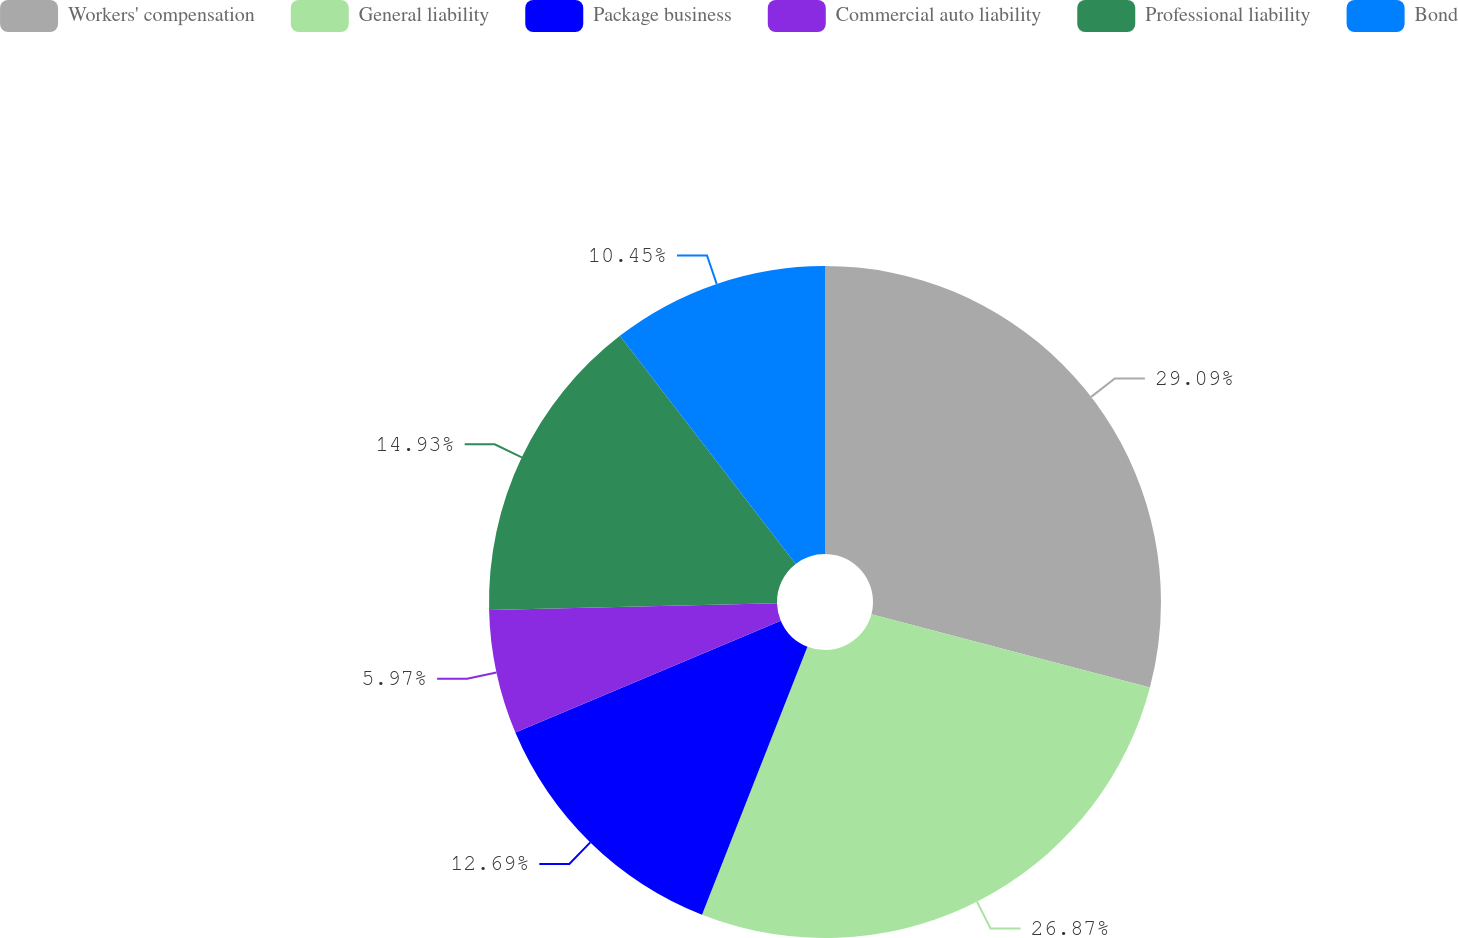Convert chart to OTSL. <chart><loc_0><loc_0><loc_500><loc_500><pie_chart><fcel>Workers' compensation<fcel>General liability<fcel>Package business<fcel>Commercial auto liability<fcel>Professional liability<fcel>Bond<nl><fcel>29.1%<fcel>26.87%<fcel>12.69%<fcel>5.97%<fcel>14.93%<fcel>10.45%<nl></chart> 